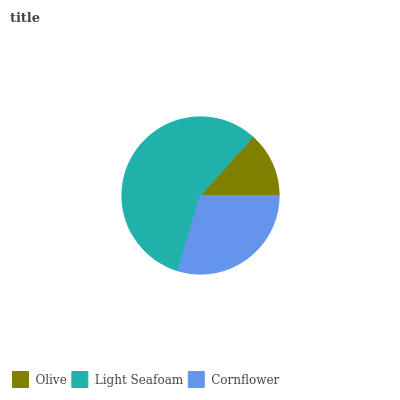Is Olive the minimum?
Answer yes or no. Yes. Is Light Seafoam the maximum?
Answer yes or no. Yes. Is Cornflower the minimum?
Answer yes or no. No. Is Cornflower the maximum?
Answer yes or no. No. Is Light Seafoam greater than Cornflower?
Answer yes or no. Yes. Is Cornflower less than Light Seafoam?
Answer yes or no. Yes. Is Cornflower greater than Light Seafoam?
Answer yes or no. No. Is Light Seafoam less than Cornflower?
Answer yes or no. No. Is Cornflower the high median?
Answer yes or no. Yes. Is Cornflower the low median?
Answer yes or no. Yes. Is Light Seafoam the high median?
Answer yes or no. No. Is Light Seafoam the low median?
Answer yes or no. No. 